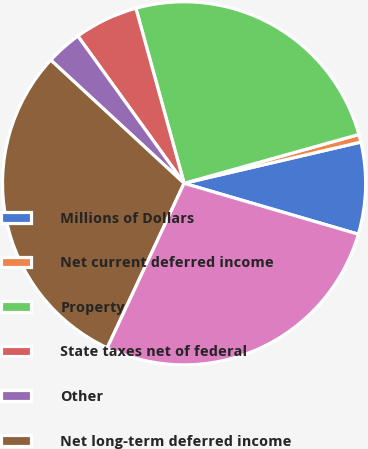Convert chart to OTSL. <chart><loc_0><loc_0><loc_500><loc_500><pie_chart><fcel>Millions of Dollars<fcel>Net current deferred income<fcel>Property<fcel>State taxes net of federal<fcel>Other<fcel>Net long-term deferred income<fcel>Net deferred income tax<nl><fcel>8.17%<fcel>0.69%<fcel>24.94%<fcel>5.67%<fcel>3.18%<fcel>29.92%<fcel>27.43%<nl></chart> 